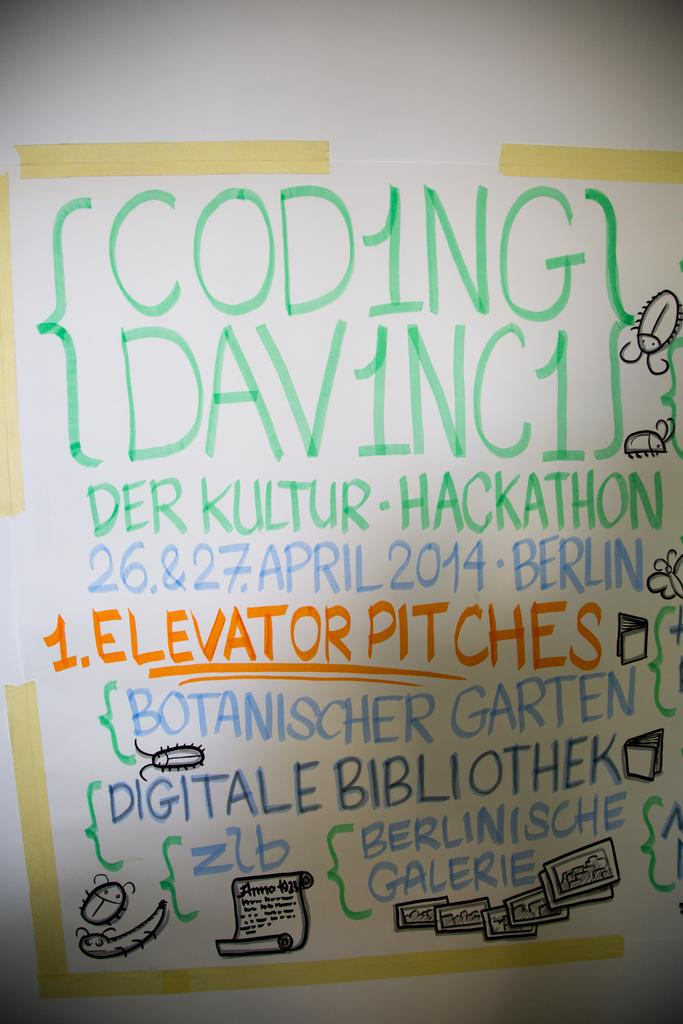<image>
Provide a brief description of the given image. A white board with hand written notes that say Der Kultur-Hackathon. 